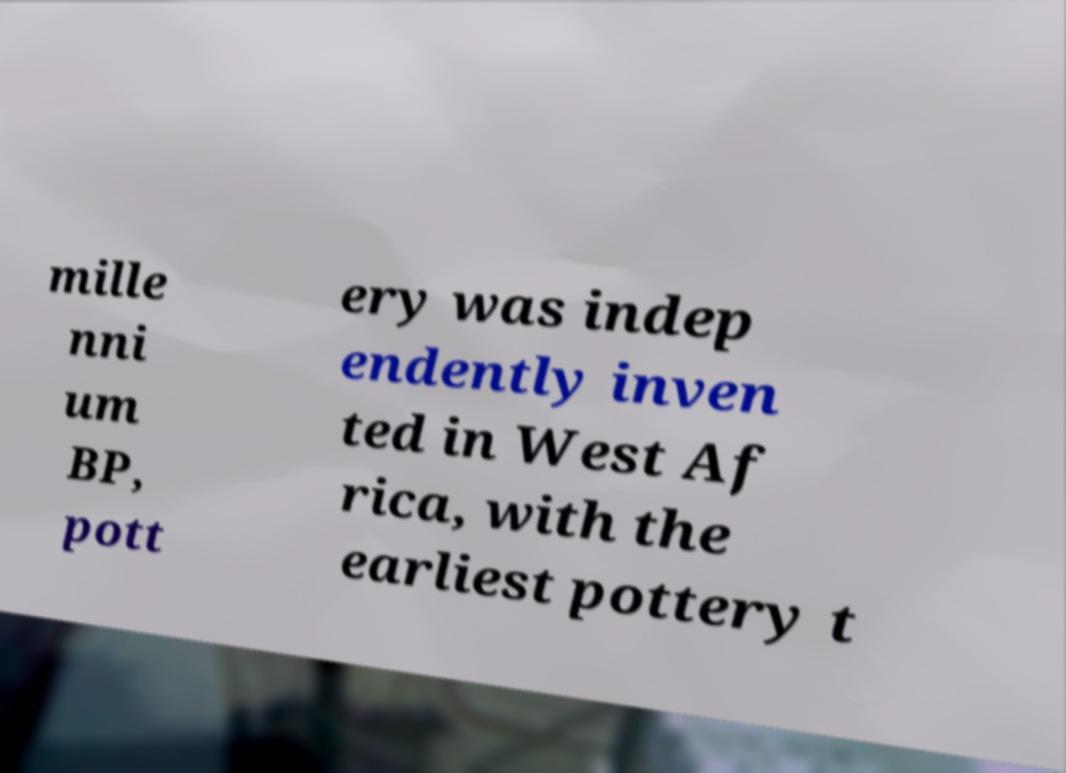Can you accurately transcribe the text from the provided image for me? mille nni um BP, pott ery was indep endently inven ted in West Af rica, with the earliest pottery t 